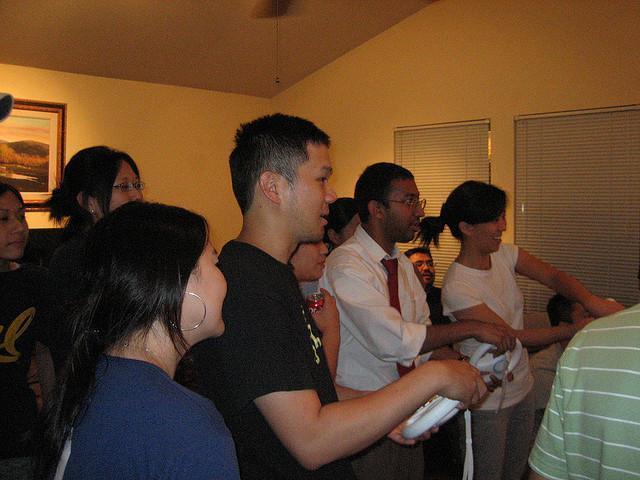How many people are there?
Give a very brief answer. 8. 